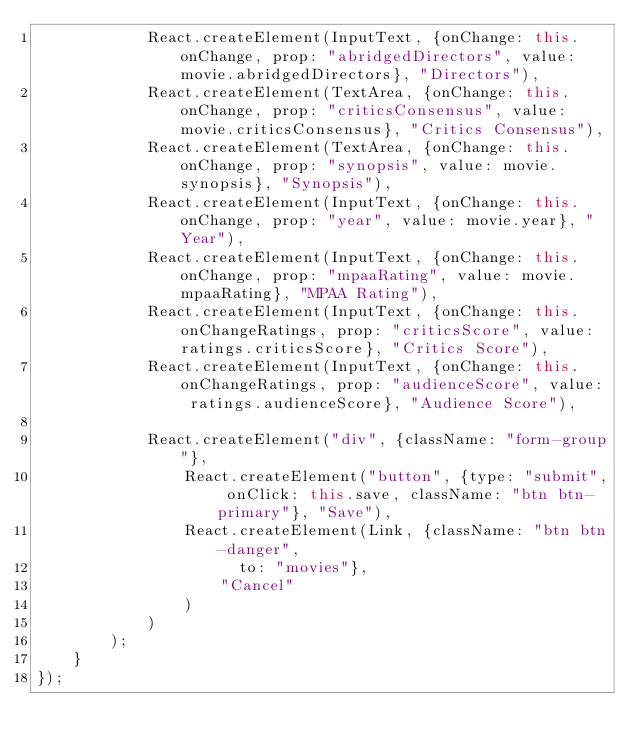Convert code to text. <code><loc_0><loc_0><loc_500><loc_500><_JavaScript_>            React.createElement(InputText, {onChange: this.onChange, prop: "abridgedDirectors", value: movie.abridgedDirectors}, "Directors"), 
            React.createElement(TextArea, {onChange: this.onChange, prop: "criticsConsensus", value: movie.criticsConsensus}, "Critics Consensus"), 
            React.createElement(TextArea, {onChange: this.onChange, prop: "synopsis", value: movie.synopsis}, "Synopsis"), 
            React.createElement(InputText, {onChange: this.onChange, prop: "year", value: movie.year}, "Year"), 
            React.createElement(InputText, {onChange: this.onChange, prop: "mpaaRating", value: movie.mpaaRating}, "MPAA Rating"), 
            React.createElement(InputText, {onChange: this.onChangeRatings, prop: "criticsScore", value: ratings.criticsScore}, "Critics Score"), 
            React.createElement(InputText, {onChange: this.onChangeRatings, prop: "audienceScore", value: ratings.audienceScore}, "Audience Score"), 

            React.createElement("div", {className: "form-group"}, 
                React.createElement("button", {type: "submit", onClick: this.save, className: "btn btn-primary"}, "Save"), 
                React.createElement(Link, {className: "btn btn-danger", 
                      to: "movies"}, 
                    "Cancel"
                )
            )
        );
    }
});
</code> 